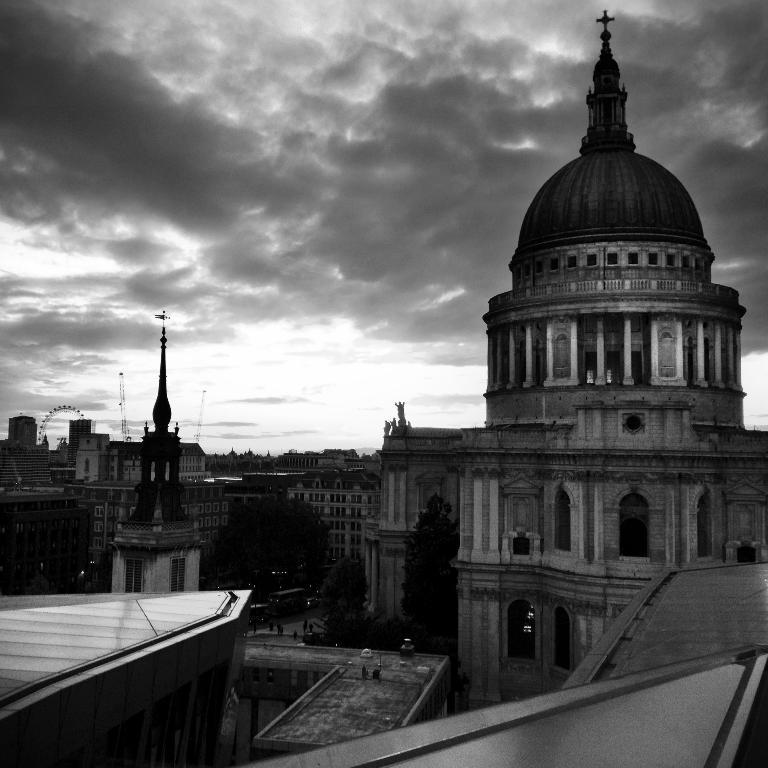What is the color scheme of the image? The image is black and white. What type of structures can be seen in the image? There are buildings in the image. What other natural elements are present in the image? There are trees in the image. Who or what else can be seen in the image? There are people in the image. What is visible in the background of the image? The sky with clouds is visible in the background of the image. What type of harmony can be heard in the image? There is no sound or music present in the image, so it is not possible to determine any type of harmony. 